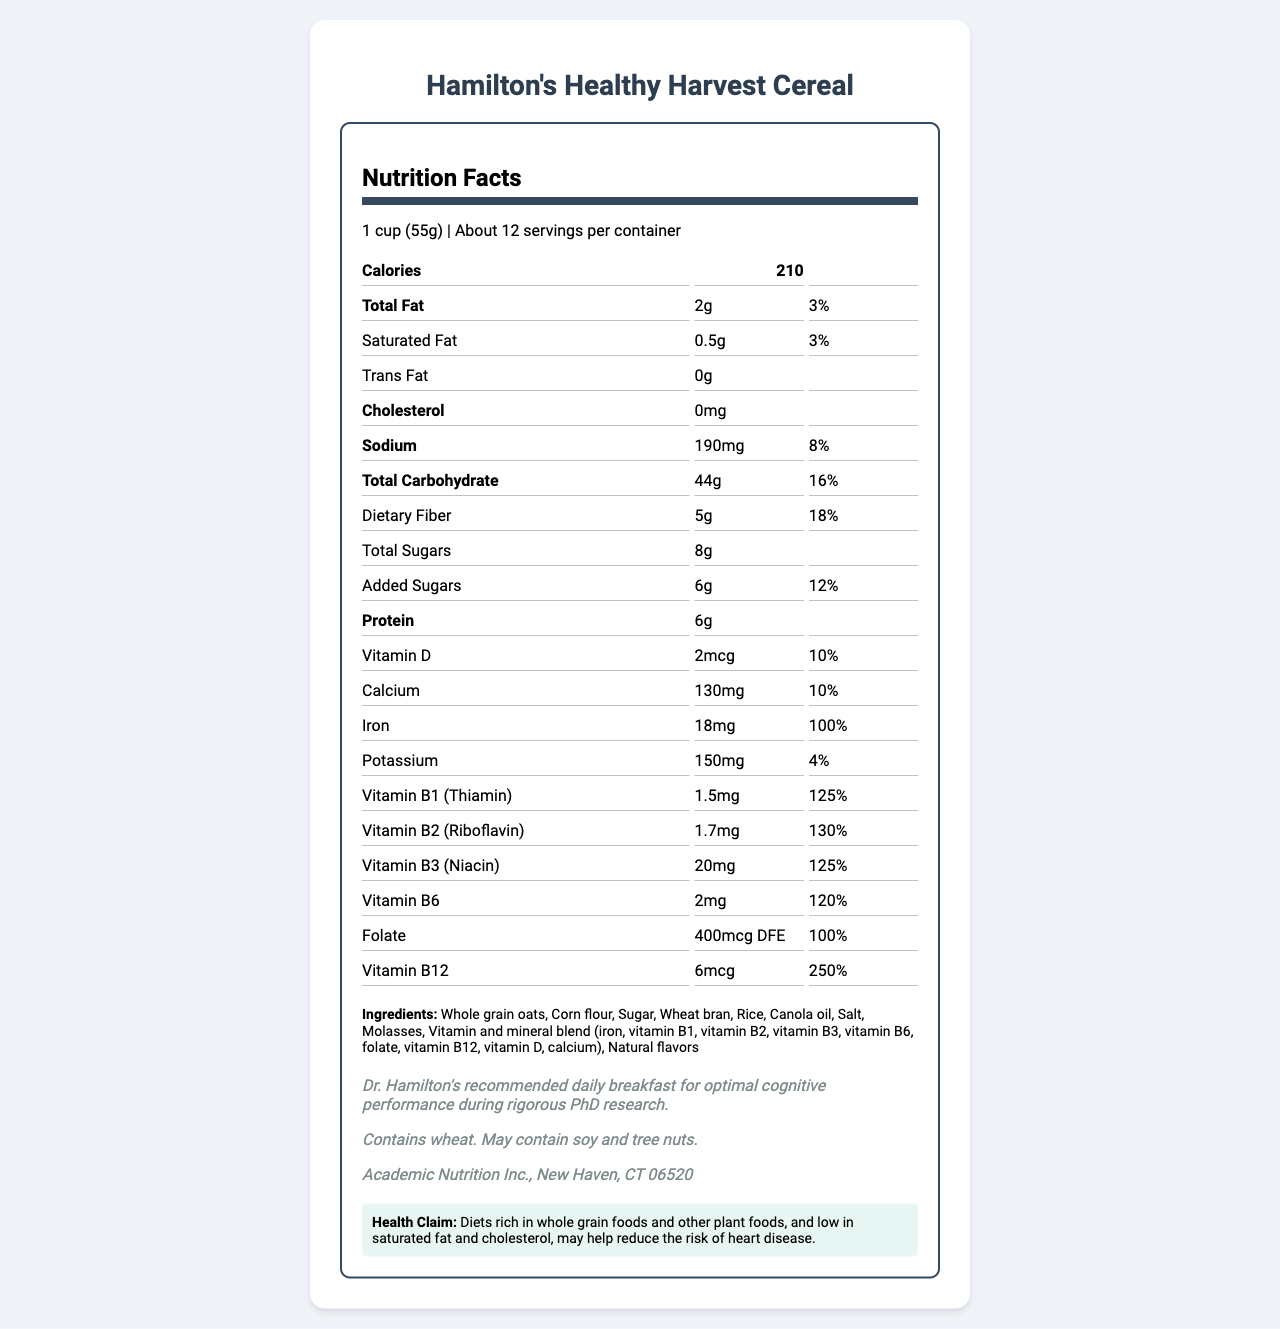what is the product name? The product name is explicitly stated at the top of the document.
Answer: Hamilton's Healthy Harvest Cereal how many calories are in one serving? The document lists the calorie count as 210 per serving.
Answer: 210 what is the serving size? The serving size is detailed next to the product name and number of servings per container.
Answer: 1 cup (55g) what percentage of daily value for Iron does one serving provide? The document indicates that one serving provides 100% of the daily value for Iron.
Answer: 100% what are the total sugars in one serving? The total sugars per serving are listed as 8g.
Answer: 8g which allergen is definitively stated to be contained in the cereal? The allergen information section specifies that the cereal contains wheat.
Answer: Wheat how much dietary fiber does one serving contain? It is listed under the nutritional facts as providing 5g of dietary fiber per serving.
Answer: 5g what is the daily value percentage of Vitamin B12 per serving? A. 125% B. 100% C. 250% D. 10% The document states that the daily value percentage for Vitamin B12 per serving is 250%.
Answer: C. 250% which ingredient is not listed in the nutrition information? A. Whole grain oats B. Eggs C. Molasses D. Corn flour Eggs are not listed among the ingredients, while whole grain oats, molasses, and corn flour are included.
Answer: B. Eggs does the cereal contain any trans fat? The document states that the trans fat content is 0g, indicating none is present.
Answer: No describe the health claim made by the cereal manufacturer The document includes this health claim as it is listed in the health claim section.
Answer: Diets rich in whole grain foods and other plant foods, and low in saturated fat and cholesterol, may help reduce the risk of heart disease. how many servings are in the container? The number of servings per container is listed as "About 12" in the document.
Answer: About 12 what is the main idea of the document? The document gives detailed nutritional information, highlights the high nutritional content, and includes a health claim about potential benefits related to heart disease.
Answer: Hamilton's Healthy Harvest Cereal provides various nutritional benefits, including a high content of B-vitamins and iron, as part of a balanced diet intended to support cognitive performance and potentially reduce the risk of heart disease. what is the whole grain content? The exact whole grain content is not specified in the document, so this information is not available.
Answer: Cannot be determined what manufacturer's information is provided? The manufacturer’s information is given in the additional info section at the bottom of the document.
Answer: Academic Nutrition Inc., New Haven, CT 06520 